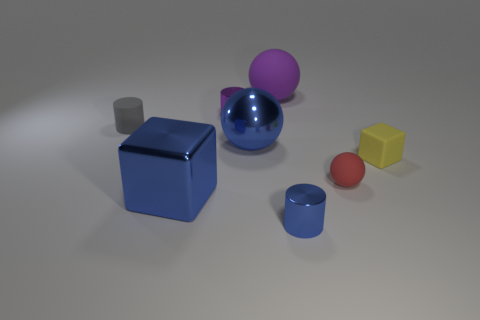There is a small cylinder that is in front of the block behind the big thing to the left of the purple cylinder; what is it made of?
Your response must be concise. Metal. How many balls are blue objects or large purple matte things?
Offer a terse response. 2. There is a small metal cylinder right of the tiny metal cylinder behind the tiny red object; how many red objects are left of it?
Your response must be concise. 0. Is the shape of the purple shiny object the same as the gray matte thing?
Keep it short and to the point. Yes. Does the cylinder to the left of the large blue shiny cube have the same material as the sphere behind the gray matte thing?
Your answer should be compact. Yes. How many objects are tiny things in front of the red object or objects that are on the right side of the tiny blue metal thing?
Keep it short and to the point. 3. What number of tiny red shiny cylinders are there?
Provide a succinct answer. 0. Are there any blue blocks that have the same size as the blue sphere?
Provide a succinct answer. Yes. Is the small yellow cube made of the same material as the object that is left of the large blue metallic cube?
Offer a very short reply. Yes. There is a block right of the tiny blue metallic object; what is it made of?
Provide a short and direct response. Rubber. 